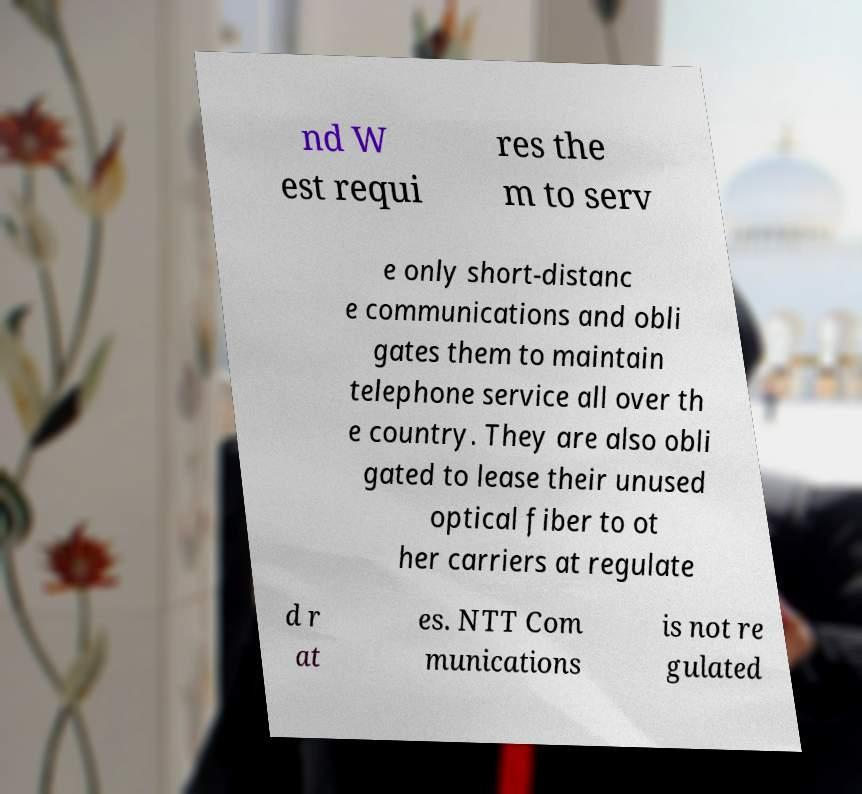Please identify and transcribe the text found in this image. nd W est requi res the m to serv e only short-distanc e communications and obli gates them to maintain telephone service all over th e country. They are also obli gated to lease their unused optical fiber to ot her carriers at regulate d r at es. NTT Com munications is not re gulated 